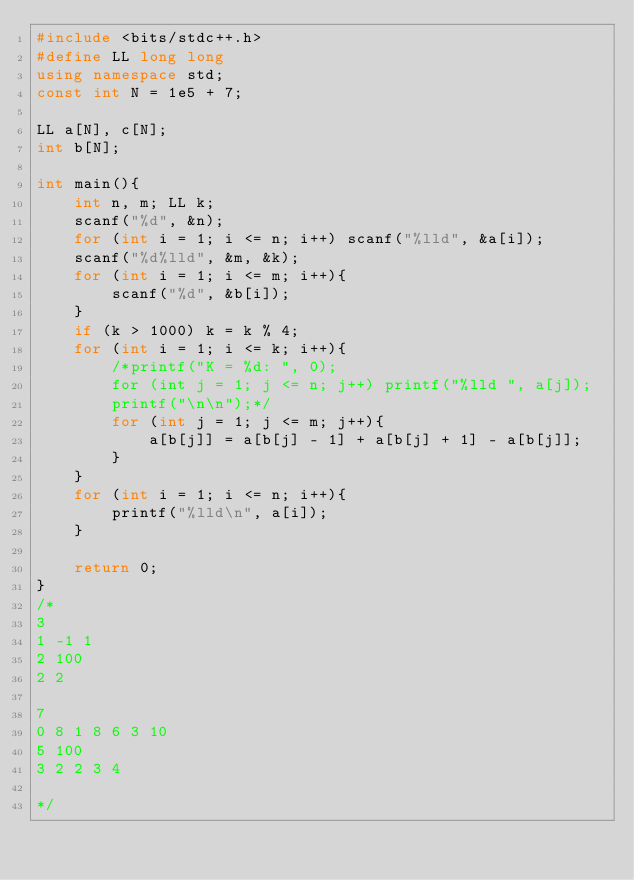<code> <loc_0><loc_0><loc_500><loc_500><_C++_>#include <bits/stdc++.h>
#define LL long long
using namespace std;
const int N = 1e5 + 7;

LL a[N], c[N];
int b[N];

int main(){
	int n, m; LL k;
	scanf("%d", &n);
	for (int i = 1; i <= n; i++) scanf("%lld", &a[i]);
	scanf("%d%lld", &m, &k);
	for (int i = 1; i <= m; i++){
		scanf("%d", &b[i]);
	}
	if (k > 1000) k = k % 4;
	for (int i = 1; i <= k; i++){
		/*printf("K = %d: ", 0);
		for (int j = 1; j <= n; j++) printf("%lld ", a[j]);
		printf("\n\n");*/
		for (int j = 1; j <= m; j++){
			a[b[j]] = a[b[j] - 1] + a[b[j] + 1] - a[b[j]];  
		}
	}
	for (int i = 1; i <= n; i++){	
		printf("%lld\n", a[i]);
	}	

	return 0;
}
/*
3
1 -1 1
2 100
2 2

7
0 8 1 8 6 3 10
5 100
3 2 2 3 4

*/
</code> 